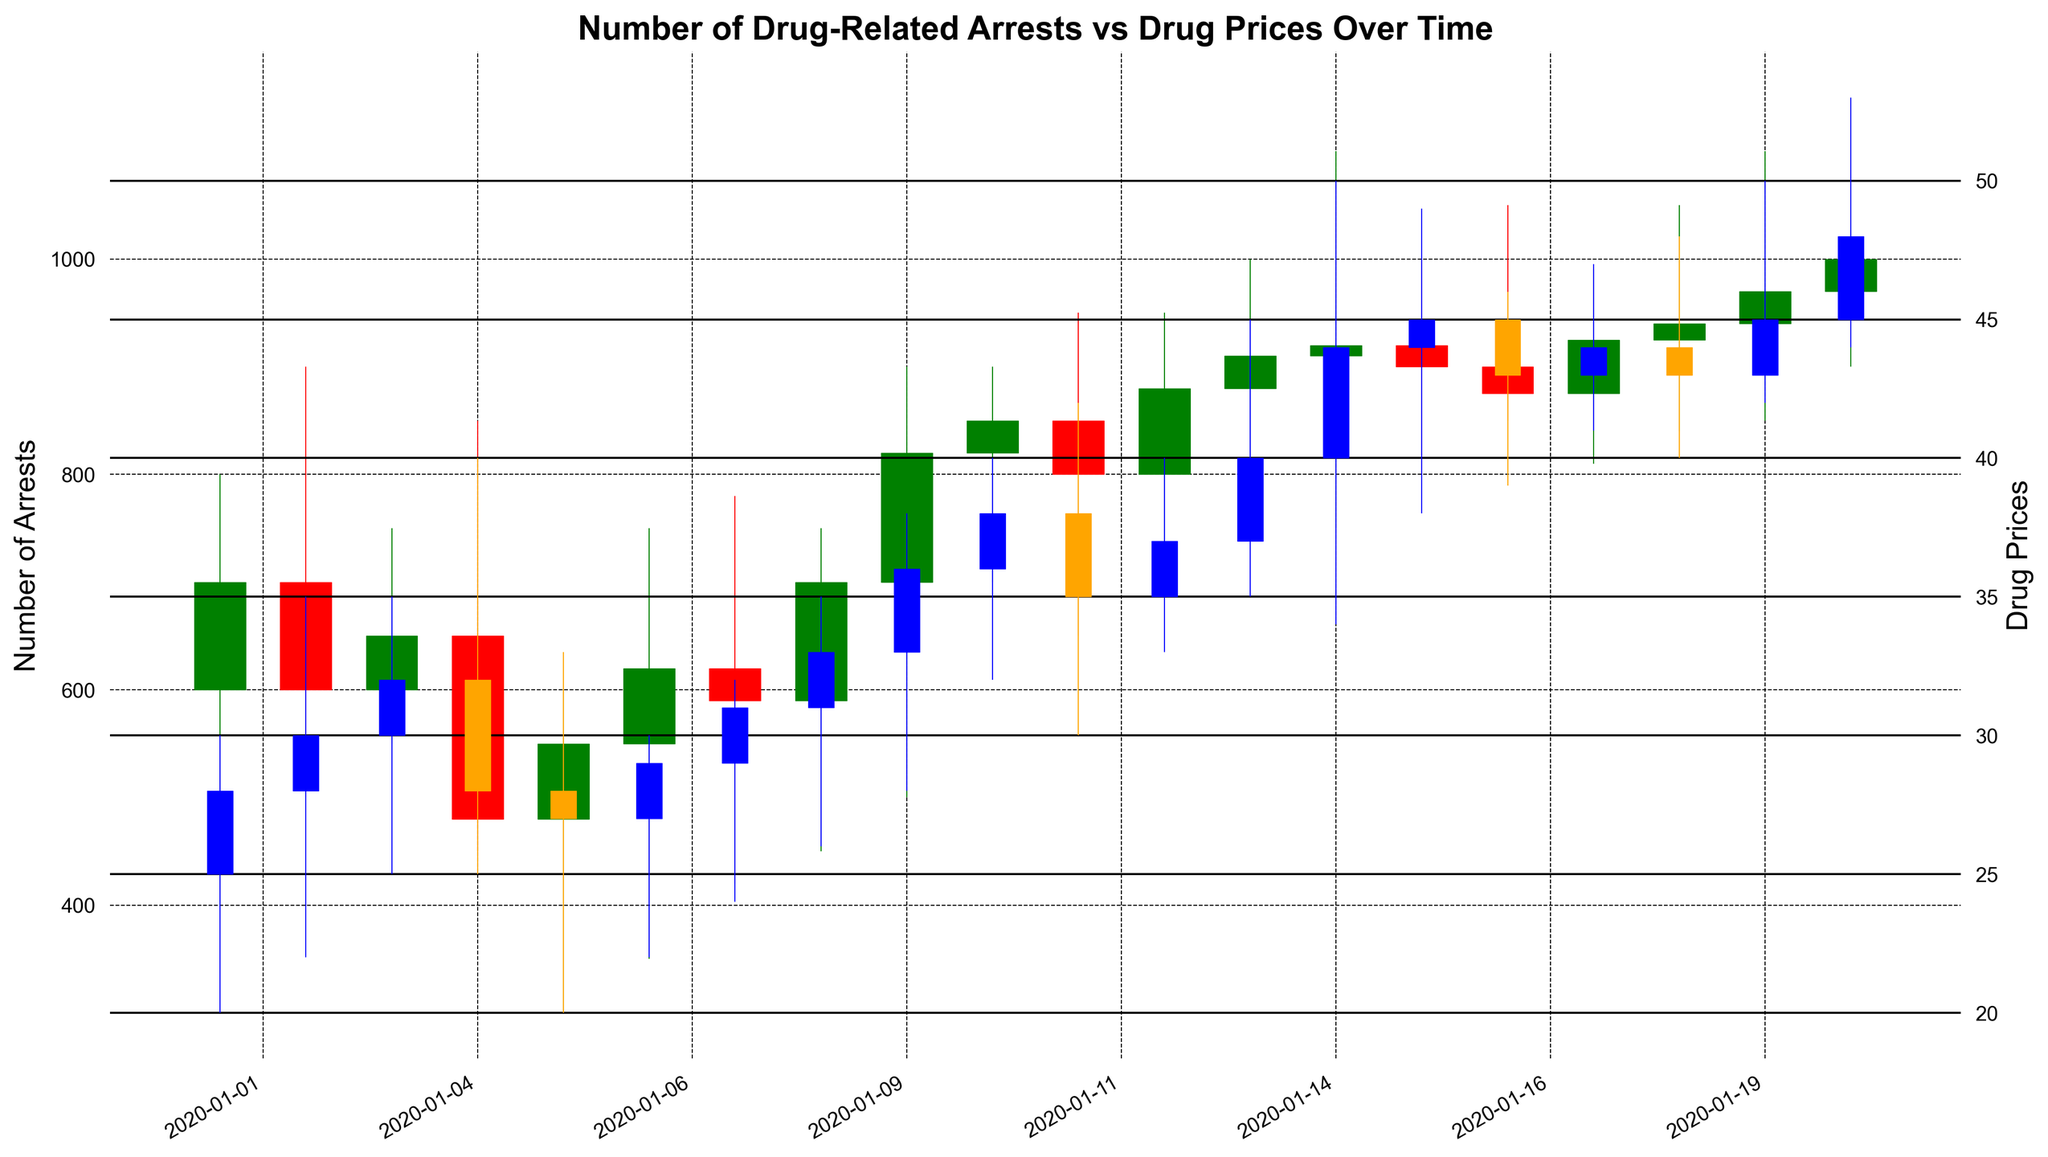What's the highest number of drug-related arrests recorded over the entire period? Look at the "HighArrests" values on the chart and identify the highest point recorded.
Answer: 1150 What's the average closing drug price over the observed period? Sum all the "ClosePrice" values and divide by the count (20). The values are 28, 30, 32, 28, 27, 29, 31, 33, 36, 38, 35, 37, 40, 44, 45, 43, 44, 43, 45, 48 leading to the total 735. So, the average is 735/20.
Answer: 36.75 On which date did the number of drug-related arrests open at the lowest value? Look at the "OpenArrests" values and identify the smallest one. Match this value to its date.
Answer: 480 on 2020-01-05 How do the trends in drug prices compare to the trends in drug-related arrests over time? Observe the visual patterns. Look for days when both arrests and prices are high or low together, as well as when they diverge. Notably, toward the end, both increments are evident.
Answer: Both trends tend to generally increase over time What's the largest daily increase in drug-related arrests? Compute the difference between "HighArrests" and "LowArrests" for each day. Look for the maximum value.
Answer: 350 on 2020-01-01 and 2020-01-16 Are there any dates where the drug price decreased but the number of arrests increased? Compare the closing prices and arrests of consecutive dates, check if price decreased and arrests increased.
Answer: Yes, on 2020-01-04 prices decreased but arrests increased What's the difference between the highest and lowest drug prices throughout the period? Identify the maximum and minimum values from the "HighPrice" and "LowPrice" columns. Subtract the minimum from the maximum value (max = 53, min = 20).
Answer: 33 How does the number of arrests on 2020-01-10 compare to that on 2020-01-20? Compare the "CloseArrests" values on these specific dates.
Answer: Arrests are higher on 2020-01-20 with 1000 compared to 850 on 2020-01-10 